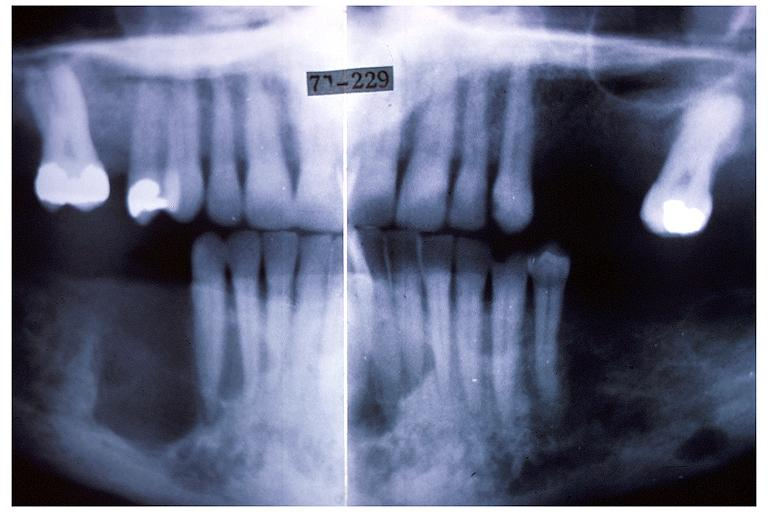s oral present?
Answer the question using a single word or phrase. Yes 